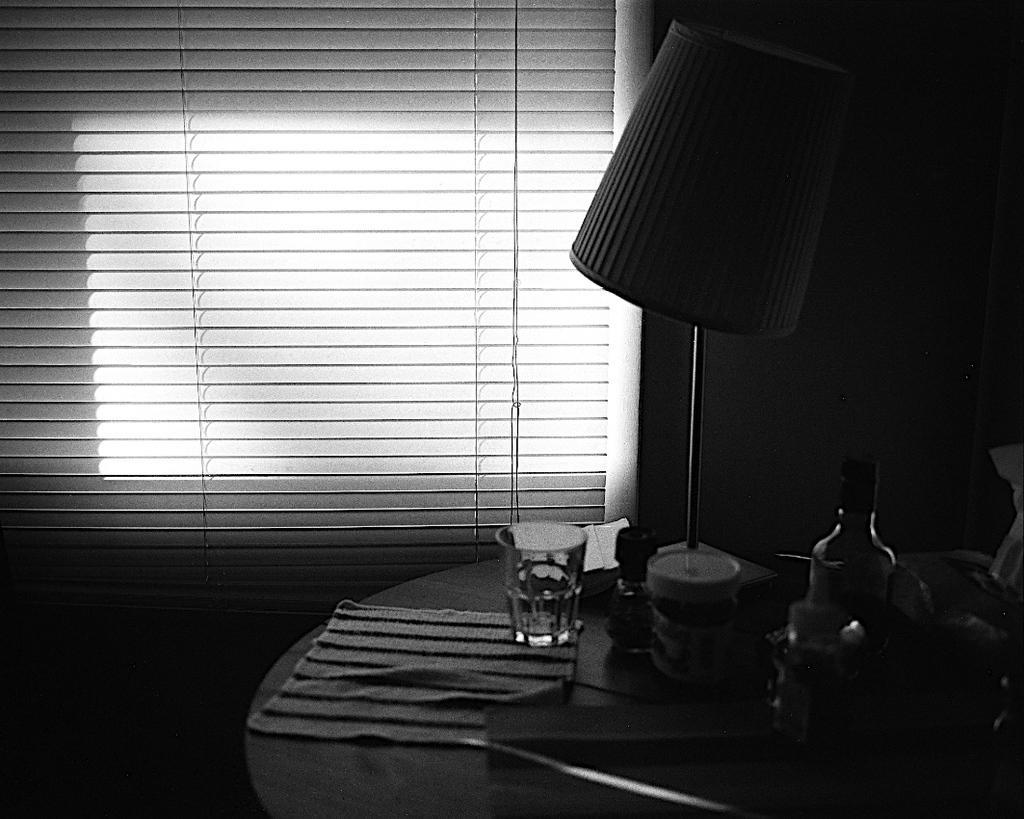In one or two sentences, can you explain what this image depicts? This is a black and white image. Here I can see a table on which cloth, glass, bottle, lamp and some more objects are placed. At the back of this table I can see a wall along with the window. 